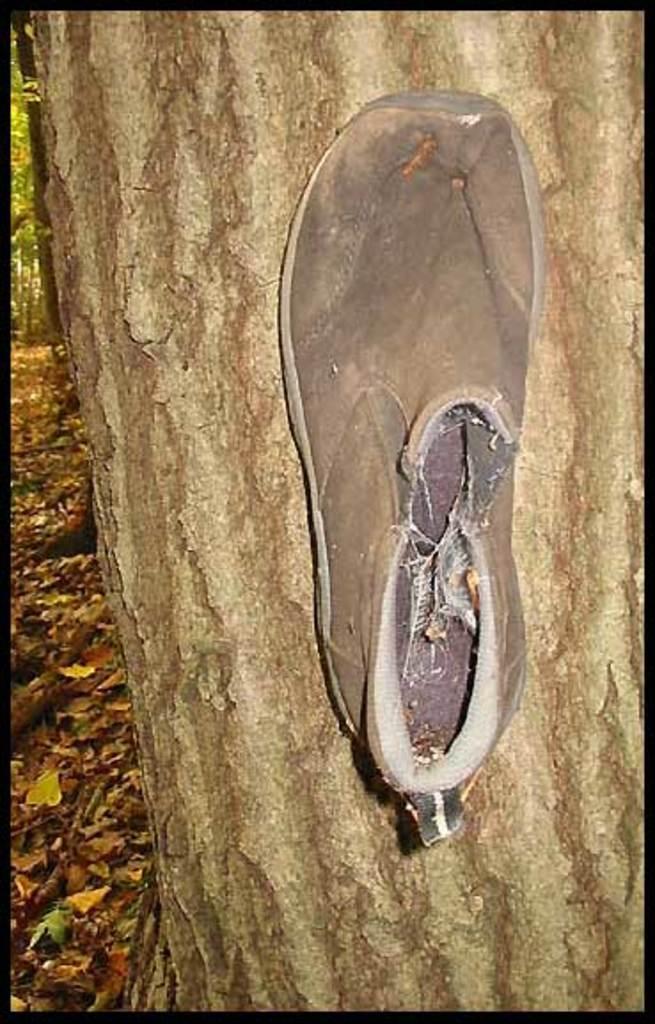Describe this image in one or two sentences. In this picture, we see a stem of the tree on which grey color shoe is placed. Beside that, we see dried leaves and twigs. 